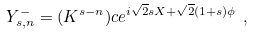<formula> <loc_0><loc_0><loc_500><loc_500>Y ^ { - } _ { s , n } = ( K ^ { s - n } ) c e ^ { i \sqrt { 2 } s X + \sqrt { 2 } ( 1 + s ) \phi } \ ,</formula> 